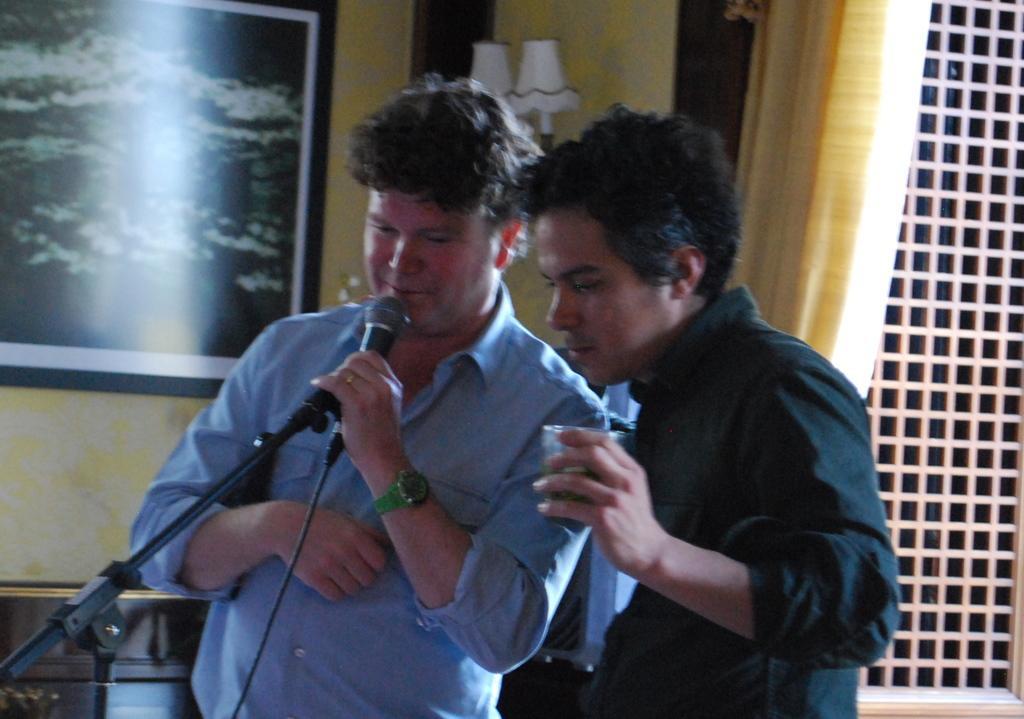Please provide a concise description of this image. Here we can see two men standing and the guy on the right side is holding a glass and the guy on the left side is holding a microphone in his hand and behind him we can see a portrait 